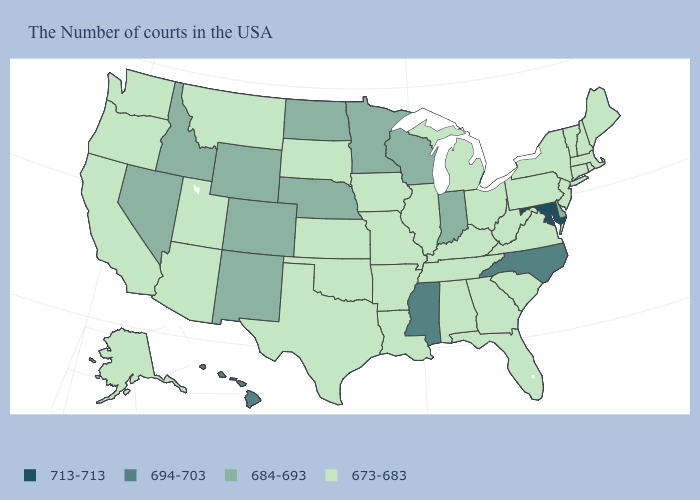What is the value of Iowa?
Be succinct. 673-683. What is the value of Rhode Island?
Short answer required. 673-683. Name the states that have a value in the range 673-683?
Give a very brief answer. Maine, Massachusetts, Rhode Island, New Hampshire, Vermont, Connecticut, New York, New Jersey, Pennsylvania, Virginia, South Carolina, West Virginia, Ohio, Florida, Georgia, Michigan, Kentucky, Alabama, Tennessee, Illinois, Louisiana, Missouri, Arkansas, Iowa, Kansas, Oklahoma, Texas, South Dakota, Utah, Montana, Arizona, California, Washington, Oregon, Alaska. Name the states that have a value in the range 684-693?
Write a very short answer. Delaware, Indiana, Wisconsin, Minnesota, Nebraska, North Dakota, Wyoming, Colorado, New Mexico, Idaho, Nevada. Name the states that have a value in the range 684-693?
Answer briefly. Delaware, Indiana, Wisconsin, Minnesota, Nebraska, North Dakota, Wyoming, Colorado, New Mexico, Idaho, Nevada. Name the states that have a value in the range 684-693?
Concise answer only. Delaware, Indiana, Wisconsin, Minnesota, Nebraska, North Dakota, Wyoming, Colorado, New Mexico, Idaho, Nevada. What is the value of Illinois?
Answer briefly. 673-683. What is the lowest value in the USA?
Give a very brief answer. 673-683. What is the lowest value in the MidWest?
Write a very short answer. 673-683. Does South Dakota have the highest value in the USA?
Quick response, please. No. What is the value of Vermont?
Quick response, please. 673-683. Name the states that have a value in the range 694-703?
Write a very short answer. North Carolina, Mississippi, Hawaii. Which states have the lowest value in the MidWest?
Be succinct. Ohio, Michigan, Illinois, Missouri, Iowa, Kansas, South Dakota. Does Hawaii have the highest value in the West?
Write a very short answer. Yes. 